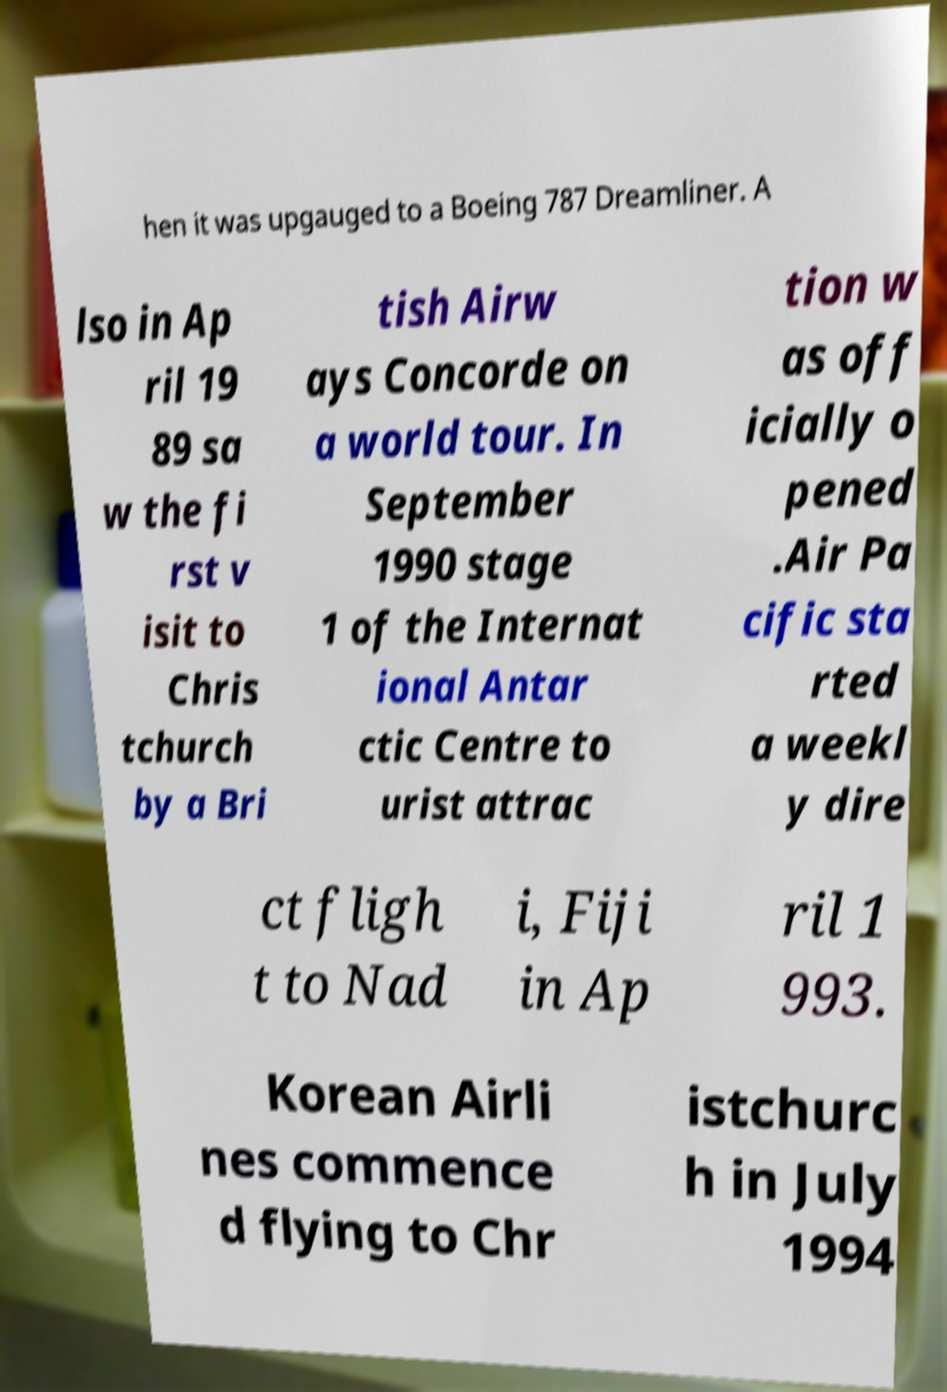Please read and relay the text visible in this image. What does it say? hen it was upgauged to a Boeing 787 Dreamliner. A lso in Ap ril 19 89 sa w the fi rst v isit to Chris tchurch by a Bri tish Airw ays Concorde on a world tour. In September 1990 stage 1 of the Internat ional Antar ctic Centre to urist attrac tion w as off icially o pened .Air Pa cific sta rted a weekl y dire ct fligh t to Nad i, Fiji in Ap ril 1 993. Korean Airli nes commence d flying to Chr istchurc h in July 1994 